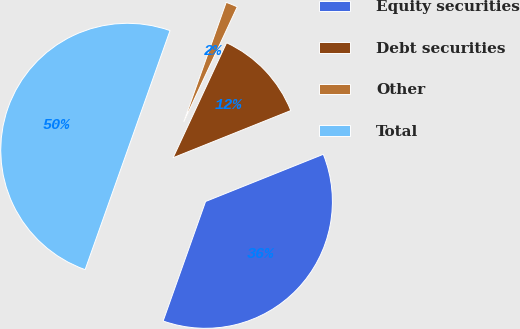Convert chart to OTSL. <chart><loc_0><loc_0><loc_500><loc_500><pie_chart><fcel>Equity securities<fcel>Debt securities<fcel>Other<fcel>Total<nl><fcel>36.5%<fcel>12.0%<fcel>1.5%<fcel>50.0%<nl></chart> 